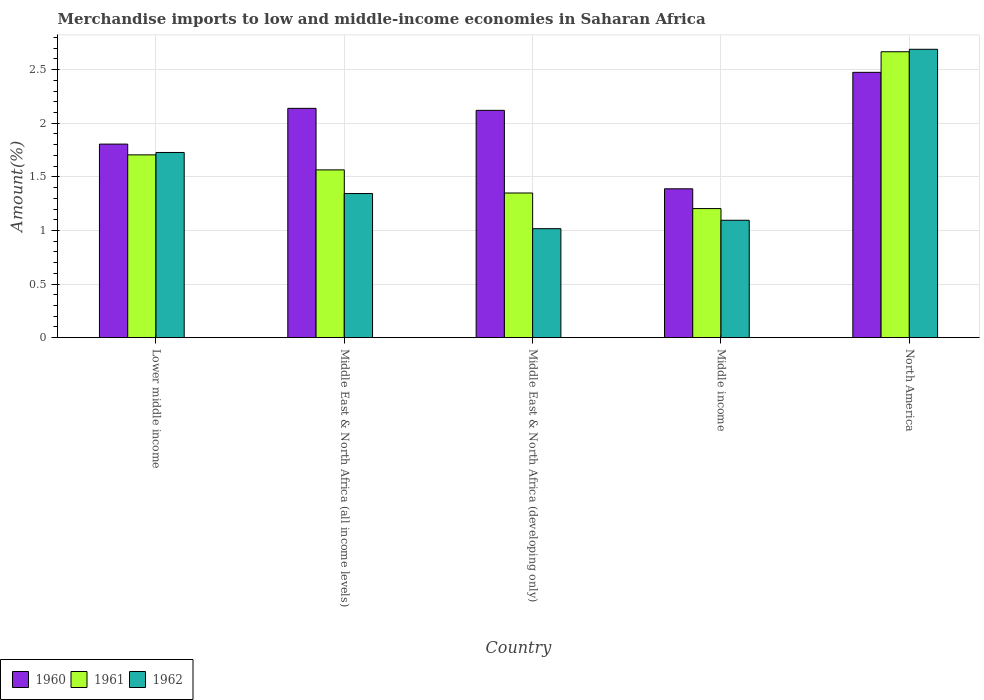How many groups of bars are there?
Make the answer very short. 5. Are the number of bars on each tick of the X-axis equal?
Offer a very short reply. Yes. What is the label of the 2nd group of bars from the left?
Provide a succinct answer. Middle East & North Africa (all income levels). What is the percentage of amount earned from merchandise imports in 1960 in Middle income?
Make the answer very short. 1.39. Across all countries, what is the maximum percentage of amount earned from merchandise imports in 1961?
Give a very brief answer. 2.67. Across all countries, what is the minimum percentage of amount earned from merchandise imports in 1962?
Keep it short and to the point. 1.02. In which country was the percentage of amount earned from merchandise imports in 1960 maximum?
Your response must be concise. North America. In which country was the percentage of amount earned from merchandise imports in 1961 minimum?
Give a very brief answer. Middle income. What is the total percentage of amount earned from merchandise imports in 1960 in the graph?
Ensure brevity in your answer.  9.93. What is the difference between the percentage of amount earned from merchandise imports in 1961 in Lower middle income and that in Middle East & North Africa (developing only)?
Provide a succinct answer. 0.36. What is the difference between the percentage of amount earned from merchandise imports in 1962 in Middle income and the percentage of amount earned from merchandise imports in 1960 in Lower middle income?
Your answer should be compact. -0.71. What is the average percentage of amount earned from merchandise imports in 1960 per country?
Your answer should be compact. 1.99. What is the difference between the percentage of amount earned from merchandise imports of/in 1962 and percentage of amount earned from merchandise imports of/in 1960 in North America?
Your response must be concise. 0.21. What is the ratio of the percentage of amount earned from merchandise imports in 1961 in Middle East & North Africa (developing only) to that in North America?
Ensure brevity in your answer.  0.51. Is the percentage of amount earned from merchandise imports in 1961 in Middle East & North Africa (developing only) less than that in Middle income?
Your answer should be very brief. No. What is the difference between the highest and the second highest percentage of amount earned from merchandise imports in 1960?
Provide a short and direct response. 0.34. What is the difference between the highest and the lowest percentage of amount earned from merchandise imports in 1960?
Offer a very short reply. 1.09. Is the sum of the percentage of amount earned from merchandise imports in 1960 in Lower middle income and Middle income greater than the maximum percentage of amount earned from merchandise imports in 1961 across all countries?
Your answer should be compact. Yes. What does the 1st bar from the left in Middle income represents?
Make the answer very short. 1960. Is it the case that in every country, the sum of the percentage of amount earned from merchandise imports in 1962 and percentage of amount earned from merchandise imports in 1960 is greater than the percentage of amount earned from merchandise imports in 1961?
Your answer should be compact. Yes. How many bars are there?
Provide a succinct answer. 15. Are the values on the major ticks of Y-axis written in scientific E-notation?
Give a very brief answer. No. How are the legend labels stacked?
Give a very brief answer. Horizontal. What is the title of the graph?
Provide a short and direct response. Merchandise imports to low and middle-income economies in Saharan Africa. Does "1984" appear as one of the legend labels in the graph?
Ensure brevity in your answer.  No. What is the label or title of the X-axis?
Provide a short and direct response. Country. What is the label or title of the Y-axis?
Give a very brief answer. Amount(%). What is the Amount(%) in 1960 in Lower middle income?
Keep it short and to the point. 1.81. What is the Amount(%) of 1961 in Lower middle income?
Provide a short and direct response. 1.71. What is the Amount(%) of 1962 in Lower middle income?
Your answer should be very brief. 1.73. What is the Amount(%) of 1960 in Middle East & North Africa (all income levels)?
Provide a succinct answer. 2.14. What is the Amount(%) of 1961 in Middle East & North Africa (all income levels)?
Your response must be concise. 1.57. What is the Amount(%) of 1962 in Middle East & North Africa (all income levels)?
Your response must be concise. 1.34. What is the Amount(%) in 1960 in Middle East & North Africa (developing only)?
Offer a very short reply. 2.12. What is the Amount(%) in 1961 in Middle East & North Africa (developing only)?
Offer a terse response. 1.35. What is the Amount(%) in 1962 in Middle East & North Africa (developing only)?
Provide a succinct answer. 1.02. What is the Amount(%) of 1960 in Middle income?
Provide a short and direct response. 1.39. What is the Amount(%) in 1961 in Middle income?
Your response must be concise. 1.2. What is the Amount(%) of 1962 in Middle income?
Your answer should be very brief. 1.1. What is the Amount(%) of 1960 in North America?
Keep it short and to the point. 2.47. What is the Amount(%) of 1961 in North America?
Offer a very short reply. 2.67. What is the Amount(%) of 1962 in North America?
Your answer should be compact. 2.69. Across all countries, what is the maximum Amount(%) of 1960?
Provide a short and direct response. 2.47. Across all countries, what is the maximum Amount(%) in 1961?
Provide a short and direct response. 2.67. Across all countries, what is the maximum Amount(%) in 1962?
Provide a succinct answer. 2.69. Across all countries, what is the minimum Amount(%) of 1960?
Ensure brevity in your answer.  1.39. Across all countries, what is the minimum Amount(%) of 1961?
Provide a succinct answer. 1.2. Across all countries, what is the minimum Amount(%) in 1962?
Offer a terse response. 1.02. What is the total Amount(%) of 1960 in the graph?
Keep it short and to the point. 9.93. What is the total Amount(%) in 1961 in the graph?
Provide a succinct answer. 8.49. What is the total Amount(%) of 1962 in the graph?
Provide a short and direct response. 7.87. What is the difference between the Amount(%) in 1960 in Lower middle income and that in Middle East & North Africa (all income levels)?
Ensure brevity in your answer.  -0.33. What is the difference between the Amount(%) of 1961 in Lower middle income and that in Middle East & North Africa (all income levels)?
Offer a terse response. 0.14. What is the difference between the Amount(%) of 1962 in Lower middle income and that in Middle East & North Africa (all income levels)?
Your response must be concise. 0.38. What is the difference between the Amount(%) of 1960 in Lower middle income and that in Middle East & North Africa (developing only)?
Make the answer very short. -0.31. What is the difference between the Amount(%) of 1961 in Lower middle income and that in Middle East & North Africa (developing only)?
Your response must be concise. 0.36. What is the difference between the Amount(%) in 1962 in Lower middle income and that in Middle East & North Africa (developing only)?
Your answer should be compact. 0.71. What is the difference between the Amount(%) of 1960 in Lower middle income and that in Middle income?
Make the answer very short. 0.42. What is the difference between the Amount(%) in 1961 in Lower middle income and that in Middle income?
Make the answer very short. 0.5. What is the difference between the Amount(%) in 1962 in Lower middle income and that in Middle income?
Offer a very short reply. 0.63. What is the difference between the Amount(%) in 1960 in Lower middle income and that in North America?
Provide a succinct answer. -0.67. What is the difference between the Amount(%) of 1961 in Lower middle income and that in North America?
Provide a short and direct response. -0.96. What is the difference between the Amount(%) of 1962 in Lower middle income and that in North America?
Keep it short and to the point. -0.96. What is the difference between the Amount(%) in 1960 in Middle East & North Africa (all income levels) and that in Middle East & North Africa (developing only)?
Provide a succinct answer. 0.02. What is the difference between the Amount(%) in 1961 in Middle East & North Africa (all income levels) and that in Middle East & North Africa (developing only)?
Your answer should be compact. 0.22. What is the difference between the Amount(%) in 1962 in Middle East & North Africa (all income levels) and that in Middle East & North Africa (developing only)?
Provide a succinct answer. 0.33. What is the difference between the Amount(%) of 1960 in Middle East & North Africa (all income levels) and that in Middle income?
Ensure brevity in your answer.  0.75. What is the difference between the Amount(%) in 1961 in Middle East & North Africa (all income levels) and that in Middle income?
Make the answer very short. 0.36. What is the difference between the Amount(%) of 1962 in Middle East & North Africa (all income levels) and that in Middle income?
Your response must be concise. 0.25. What is the difference between the Amount(%) in 1960 in Middle East & North Africa (all income levels) and that in North America?
Offer a terse response. -0.34. What is the difference between the Amount(%) in 1961 in Middle East & North Africa (all income levels) and that in North America?
Provide a succinct answer. -1.1. What is the difference between the Amount(%) of 1962 in Middle East & North Africa (all income levels) and that in North America?
Your answer should be very brief. -1.35. What is the difference between the Amount(%) in 1960 in Middle East & North Africa (developing only) and that in Middle income?
Your answer should be very brief. 0.73. What is the difference between the Amount(%) of 1961 in Middle East & North Africa (developing only) and that in Middle income?
Provide a short and direct response. 0.15. What is the difference between the Amount(%) in 1962 in Middle East & North Africa (developing only) and that in Middle income?
Provide a short and direct response. -0.08. What is the difference between the Amount(%) of 1960 in Middle East & North Africa (developing only) and that in North America?
Provide a succinct answer. -0.35. What is the difference between the Amount(%) in 1961 in Middle East & North Africa (developing only) and that in North America?
Make the answer very short. -1.32. What is the difference between the Amount(%) in 1962 in Middle East & North Africa (developing only) and that in North America?
Your answer should be very brief. -1.67. What is the difference between the Amount(%) in 1960 in Middle income and that in North America?
Ensure brevity in your answer.  -1.09. What is the difference between the Amount(%) of 1961 in Middle income and that in North America?
Provide a short and direct response. -1.46. What is the difference between the Amount(%) of 1962 in Middle income and that in North America?
Offer a very short reply. -1.59. What is the difference between the Amount(%) of 1960 in Lower middle income and the Amount(%) of 1961 in Middle East & North Africa (all income levels)?
Ensure brevity in your answer.  0.24. What is the difference between the Amount(%) in 1960 in Lower middle income and the Amount(%) in 1962 in Middle East & North Africa (all income levels)?
Your answer should be compact. 0.46. What is the difference between the Amount(%) of 1961 in Lower middle income and the Amount(%) of 1962 in Middle East & North Africa (all income levels)?
Offer a terse response. 0.36. What is the difference between the Amount(%) of 1960 in Lower middle income and the Amount(%) of 1961 in Middle East & North Africa (developing only)?
Ensure brevity in your answer.  0.46. What is the difference between the Amount(%) of 1960 in Lower middle income and the Amount(%) of 1962 in Middle East & North Africa (developing only)?
Make the answer very short. 0.79. What is the difference between the Amount(%) of 1961 in Lower middle income and the Amount(%) of 1962 in Middle East & North Africa (developing only)?
Offer a terse response. 0.69. What is the difference between the Amount(%) of 1960 in Lower middle income and the Amount(%) of 1961 in Middle income?
Make the answer very short. 0.6. What is the difference between the Amount(%) in 1960 in Lower middle income and the Amount(%) in 1962 in Middle income?
Make the answer very short. 0.71. What is the difference between the Amount(%) of 1961 in Lower middle income and the Amount(%) of 1962 in Middle income?
Provide a succinct answer. 0.61. What is the difference between the Amount(%) in 1960 in Lower middle income and the Amount(%) in 1961 in North America?
Provide a succinct answer. -0.86. What is the difference between the Amount(%) of 1960 in Lower middle income and the Amount(%) of 1962 in North America?
Provide a short and direct response. -0.88. What is the difference between the Amount(%) of 1961 in Lower middle income and the Amount(%) of 1962 in North America?
Ensure brevity in your answer.  -0.98. What is the difference between the Amount(%) in 1960 in Middle East & North Africa (all income levels) and the Amount(%) in 1961 in Middle East & North Africa (developing only)?
Provide a succinct answer. 0.79. What is the difference between the Amount(%) in 1960 in Middle East & North Africa (all income levels) and the Amount(%) in 1962 in Middle East & North Africa (developing only)?
Your answer should be compact. 1.12. What is the difference between the Amount(%) in 1961 in Middle East & North Africa (all income levels) and the Amount(%) in 1962 in Middle East & North Africa (developing only)?
Keep it short and to the point. 0.55. What is the difference between the Amount(%) in 1960 in Middle East & North Africa (all income levels) and the Amount(%) in 1961 in Middle income?
Your response must be concise. 0.93. What is the difference between the Amount(%) of 1960 in Middle East & North Africa (all income levels) and the Amount(%) of 1962 in Middle income?
Ensure brevity in your answer.  1.04. What is the difference between the Amount(%) of 1961 in Middle East & North Africa (all income levels) and the Amount(%) of 1962 in Middle income?
Keep it short and to the point. 0.47. What is the difference between the Amount(%) of 1960 in Middle East & North Africa (all income levels) and the Amount(%) of 1961 in North America?
Make the answer very short. -0.53. What is the difference between the Amount(%) in 1960 in Middle East & North Africa (all income levels) and the Amount(%) in 1962 in North America?
Ensure brevity in your answer.  -0.55. What is the difference between the Amount(%) of 1961 in Middle East & North Africa (all income levels) and the Amount(%) of 1962 in North America?
Give a very brief answer. -1.12. What is the difference between the Amount(%) of 1960 in Middle East & North Africa (developing only) and the Amount(%) of 1961 in Middle income?
Ensure brevity in your answer.  0.92. What is the difference between the Amount(%) in 1960 in Middle East & North Africa (developing only) and the Amount(%) in 1962 in Middle income?
Give a very brief answer. 1.03. What is the difference between the Amount(%) in 1961 in Middle East & North Africa (developing only) and the Amount(%) in 1962 in Middle income?
Your answer should be compact. 0.25. What is the difference between the Amount(%) of 1960 in Middle East & North Africa (developing only) and the Amount(%) of 1961 in North America?
Ensure brevity in your answer.  -0.55. What is the difference between the Amount(%) of 1960 in Middle East & North Africa (developing only) and the Amount(%) of 1962 in North America?
Your answer should be compact. -0.57. What is the difference between the Amount(%) in 1961 in Middle East & North Africa (developing only) and the Amount(%) in 1962 in North America?
Your answer should be compact. -1.34. What is the difference between the Amount(%) in 1960 in Middle income and the Amount(%) in 1961 in North America?
Give a very brief answer. -1.28. What is the difference between the Amount(%) of 1960 in Middle income and the Amount(%) of 1962 in North America?
Your response must be concise. -1.3. What is the difference between the Amount(%) in 1961 in Middle income and the Amount(%) in 1962 in North America?
Your answer should be very brief. -1.49. What is the average Amount(%) in 1960 per country?
Your response must be concise. 1.99. What is the average Amount(%) in 1961 per country?
Your response must be concise. 1.7. What is the average Amount(%) in 1962 per country?
Ensure brevity in your answer.  1.57. What is the difference between the Amount(%) of 1960 and Amount(%) of 1961 in Lower middle income?
Keep it short and to the point. 0.1. What is the difference between the Amount(%) in 1960 and Amount(%) in 1962 in Lower middle income?
Keep it short and to the point. 0.08. What is the difference between the Amount(%) in 1961 and Amount(%) in 1962 in Lower middle income?
Provide a short and direct response. -0.02. What is the difference between the Amount(%) in 1960 and Amount(%) in 1961 in Middle East & North Africa (all income levels)?
Provide a succinct answer. 0.57. What is the difference between the Amount(%) in 1960 and Amount(%) in 1962 in Middle East & North Africa (all income levels)?
Your answer should be very brief. 0.79. What is the difference between the Amount(%) of 1961 and Amount(%) of 1962 in Middle East & North Africa (all income levels)?
Offer a very short reply. 0.22. What is the difference between the Amount(%) of 1960 and Amount(%) of 1961 in Middle East & North Africa (developing only)?
Your response must be concise. 0.77. What is the difference between the Amount(%) in 1960 and Amount(%) in 1962 in Middle East & North Africa (developing only)?
Your answer should be very brief. 1.1. What is the difference between the Amount(%) of 1961 and Amount(%) of 1962 in Middle East & North Africa (developing only)?
Give a very brief answer. 0.33. What is the difference between the Amount(%) in 1960 and Amount(%) in 1961 in Middle income?
Your response must be concise. 0.18. What is the difference between the Amount(%) of 1960 and Amount(%) of 1962 in Middle income?
Ensure brevity in your answer.  0.29. What is the difference between the Amount(%) of 1961 and Amount(%) of 1962 in Middle income?
Your response must be concise. 0.11. What is the difference between the Amount(%) of 1960 and Amount(%) of 1961 in North America?
Give a very brief answer. -0.19. What is the difference between the Amount(%) in 1960 and Amount(%) in 1962 in North America?
Offer a very short reply. -0.21. What is the difference between the Amount(%) of 1961 and Amount(%) of 1962 in North America?
Provide a succinct answer. -0.02. What is the ratio of the Amount(%) in 1960 in Lower middle income to that in Middle East & North Africa (all income levels)?
Keep it short and to the point. 0.84. What is the ratio of the Amount(%) of 1961 in Lower middle income to that in Middle East & North Africa (all income levels)?
Your response must be concise. 1.09. What is the ratio of the Amount(%) of 1962 in Lower middle income to that in Middle East & North Africa (all income levels)?
Your answer should be compact. 1.28. What is the ratio of the Amount(%) of 1960 in Lower middle income to that in Middle East & North Africa (developing only)?
Give a very brief answer. 0.85. What is the ratio of the Amount(%) in 1961 in Lower middle income to that in Middle East & North Africa (developing only)?
Give a very brief answer. 1.26. What is the ratio of the Amount(%) in 1962 in Lower middle income to that in Middle East & North Africa (developing only)?
Provide a succinct answer. 1.7. What is the ratio of the Amount(%) in 1960 in Lower middle income to that in Middle income?
Your answer should be compact. 1.3. What is the ratio of the Amount(%) of 1961 in Lower middle income to that in Middle income?
Keep it short and to the point. 1.42. What is the ratio of the Amount(%) of 1962 in Lower middle income to that in Middle income?
Make the answer very short. 1.58. What is the ratio of the Amount(%) in 1960 in Lower middle income to that in North America?
Your answer should be very brief. 0.73. What is the ratio of the Amount(%) of 1961 in Lower middle income to that in North America?
Make the answer very short. 0.64. What is the ratio of the Amount(%) of 1962 in Lower middle income to that in North America?
Offer a terse response. 0.64. What is the ratio of the Amount(%) of 1960 in Middle East & North Africa (all income levels) to that in Middle East & North Africa (developing only)?
Your answer should be very brief. 1.01. What is the ratio of the Amount(%) of 1961 in Middle East & North Africa (all income levels) to that in Middle East & North Africa (developing only)?
Provide a succinct answer. 1.16. What is the ratio of the Amount(%) in 1962 in Middle East & North Africa (all income levels) to that in Middle East & North Africa (developing only)?
Provide a short and direct response. 1.32. What is the ratio of the Amount(%) in 1960 in Middle East & North Africa (all income levels) to that in Middle income?
Your response must be concise. 1.54. What is the ratio of the Amount(%) in 1961 in Middle East & North Africa (all income levels) to that in Middle income?
Give a very brief answer. 1.3. What is the ratio of the Amount(%) of 1962 in Middle East & North Africa (all income levels) to that in Middle income?
Your answer should be compact. 1.23. What is the ratio of the Amount(%) in 1960 in Middle East & North Africa (all income levels) to that in North America?
Your answer should be compact. 0.86. What is the ratio of the Amount(%) of 1961 in Middle East & North Africa (all income levels) to that in North America?
Provide a succinct answer. 0.59. What is the ratio of the Amount(%) in 1962 in Middle East & North Africa (all income levels) to that in North America?
Ensure brevity in your answer.  0.5. What is the ratio of the Amount(%) in 1960 in Middle East & North Africa (developing only) to that in Middle income?
Provide a succinct answer. 1.53. What is the ratio of the Amount(%) in 1961 in Middle East & North Africa (developing only) to that in Middle income?
Make the answer very short. 1.12. What is the ratio of the Amount(%) in 1962 in Middle East & North Africa (developing only) to that in Middle income?
Keep it short and to the point. 0.93. What is the ratio of the Amount(%) of 1960 in Middle East & North Africa (developing only) to that in North America?
Ensure brevity in your answer.  0.86. What is the ratio of the Amount(%) in 1961 in Middle East & North Africa (developing only) to that in North America?
Your answer should be compact. 0.51. What is the ratio of the Amount(%) of 1962 in Middle East & North Africa (developing only) to that in North America?
Make the answer very short. 0.38. What is the ratio of the Amount(%) in 1960 in Middle income to that in North America?
Ensure brevity in your answer.  0.56. What is the ratio of the Amount(%) of 1961 in Middle income to that in North America?
Your answer should be compact. 0.45. What is the ratio of the Amount(%) in 1962 in Middle income to that in North America?
Provide a short and direct response. 0.41. What is the difference between the highest and the second highest Amount(%) in 1960?
Offer a very short reply. 0.34. What is the difference between the highest and the second highest Amount(%) of 1961?
Provide a short and direct response. 0.96. What is the difference between the highest and the second highest Amount(%) of 1962?
Offer a very short reply. 0.96. What is the difference between the highest and the lowest Amount(%) in 1960?
Keep it short and to the point. 1.09. What is the difference between the highest and the lowest Amount(%) in 1961?
Ensure brevity in your answer.  1.46. What is the difference between the highest and the lowest Amount(%) of 1962?
Your response must be concise. 1.67. 